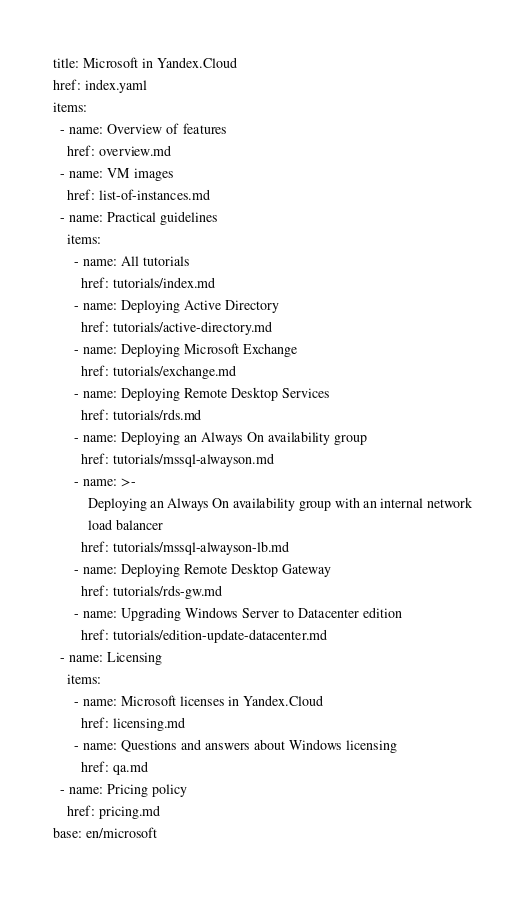<code> <loc_0><loc_0><loc_500><loc_500><_YAML_>title: Microsoft in Yandex.Cloud
href: index.yaml
items:
  - name: Overview of features
    href: overview.md
  - name: VM images
    href: list-of-instances.md
  - name: Practical guidelines
    items:
      - name: All tutorials
        href: tutorials/index.md
      - name: Deploying Active Directory
        href: tutorials/active-directory.md
      - name: Deploying Microsoft Exchange
        href: tutorials/exchange.md
      - name: Deploying Remote Desktop Services
        href: tutorials/rds.md
      - name: Deploying an Always On availability group
        href: tutorials/mssql-alwayson.md
      - name: >-
          Deploying an Always On availability group with an internal network
          load balancer
        href: tutorials/mssql-alwayson-lb.md
      - name: Deploying Remote Desktop Gateway
        href: tutorials/rds-gw.md
      - name: Upgrading Windows Server to Datacenter edition
        href: tutorials/edition-update-datacenter.md
  - name: Licensing
    items:
      - name: Microsoft licenses in Yandex.Cloud
        href: licensing.md
      - name: Questions and answers about Windows licensing
        href: qa.md
  - name: Pricing policy
    href: pricing.md
base: en/microsoft
</code> 